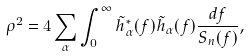<formula> <loc_0><loc_0><loc_500><loc_500>\rho ^ { 2 } = 4 \sum _ { \alpha } \int _ { 0 } ^ { \infty } \tilde { h } _ { \alpha } ^ { * } ( f ) \tilde { h } _ { \alpha } ( f ) \frac { d f } { S _ { n } ( f ) } ,</formula> 